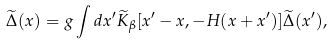Convert formula to latex. <formula><loc_0><loc_0><loc_500><loc_500>\widetilde { \Delta } ( x ) = g \int d x ^ { \prime } \widetilde { K } _ { \beta } [ x ^ { \prime } - x , - H ( x + x ^ { \prime } ) ] \widetilde { \Delta } ( x ^ { \prime } ) ,</formula> 